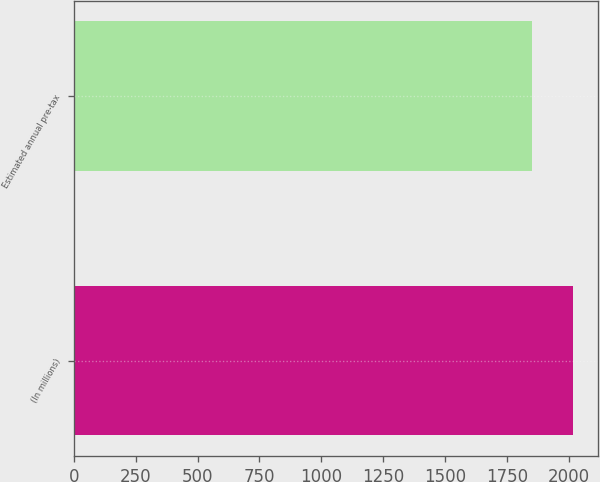<chart> <loc_0><loc_0><loc_500><loc_500><bar_chart><fcel>(In millions)<fcel>Estimated annual pre-tax<nl><fcel>2017<fcel>1853<nl></chart> 